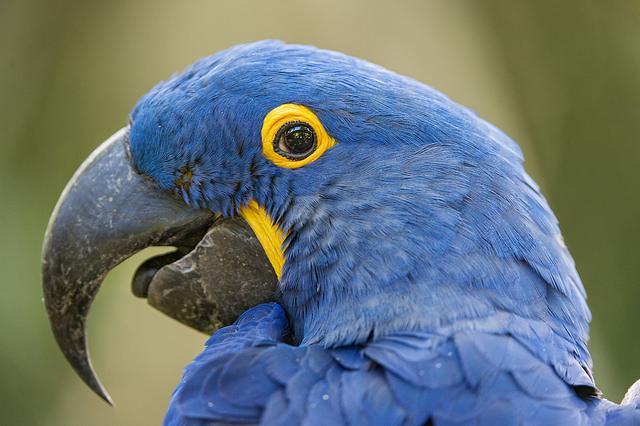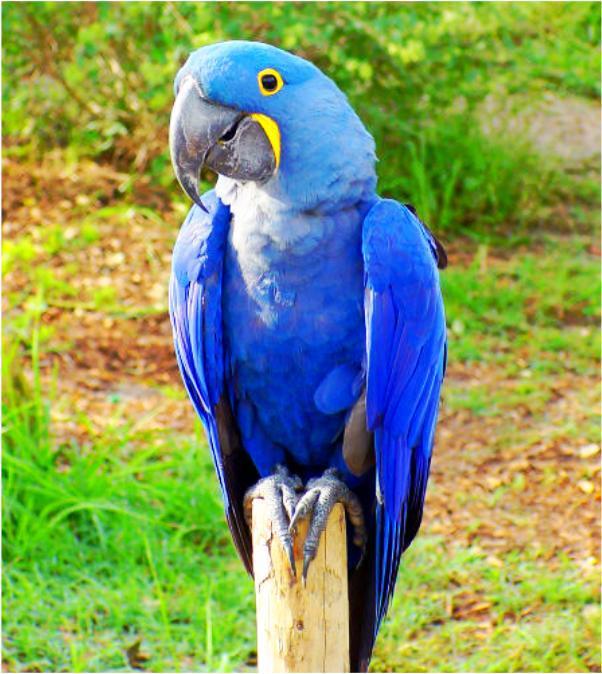The first image is the image on the left, the second image is the image on the right. For the images displayed, is the sentence "Each image contains at least two blue-feathered birds, and one image shows birds perched on leafless branches." factually correct? Answer yes or no. No. The first image is the image on the left, the second image is the image on the right. Analyze the images presented: Is the assertion "The right image contains at least two blue parrots." valid? Answer yes or no. No. 